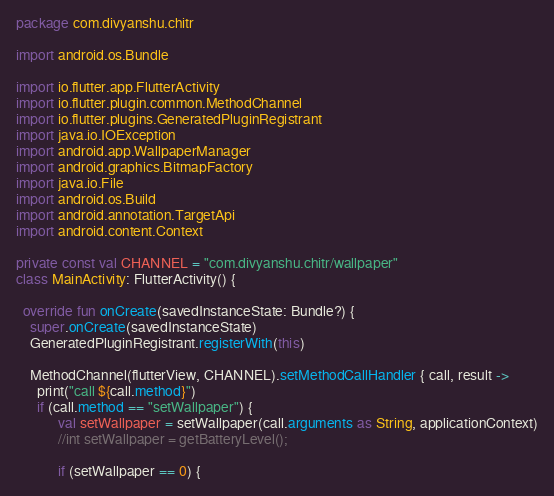Convert code to text. <code><loc_0><loc_0><loc_500><loc_500><_Kotlin_>package com.divyanshu.chitr

import android.os.Bundle

import io.flutter.app.FlutterActivity
import io.flutter.plugin.common.MethodChannel
import io.flutter.plugins.GeneratedPluginRegistrant
import java.io.IOException
import android.app.WallpaperManager
import android.graphics.BitmapFactory
import java.io.File
import android.os.Build
import android.annotation.TargetApi
import android.content.Context

private const val CHANNEL = "com.divyanshu.chitr/wallpaper"
class MainActivity: FlutterActivity() {

  override fun onCreate(savedInstanceState: Bundle?) {
    super.onCreate(savedInstanceState)
    GeneratedPluginRegistrant.registerWith(this)

    MethodChannel(flutterView, CHANNEL).setMethodCallHandler { call, result ->
      print("call ${call.method}")
      if (call.method == "setWallpaper") {
            val setWallpaper = setWallpaper(call.arguments as String, applicationContext)
            //int setWallpaper = getBatteryLevel();

            if (setWallpaper == 0) {</code> 